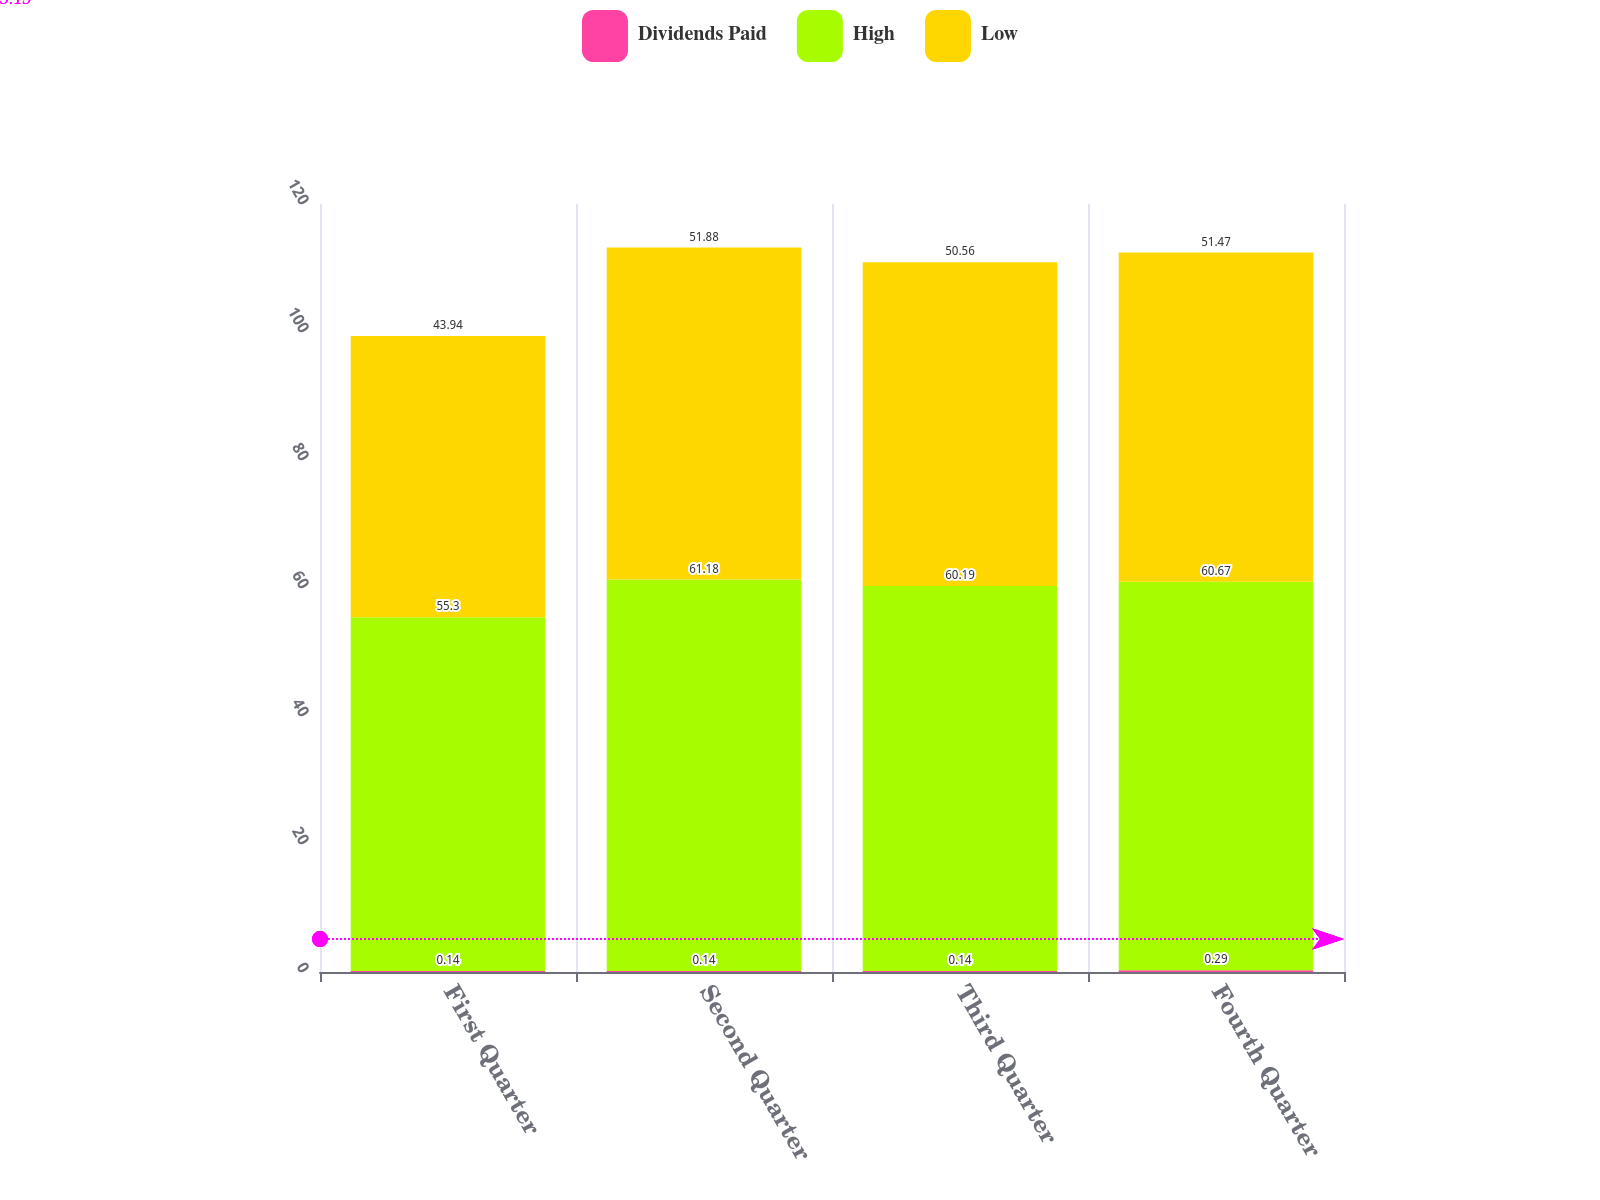Convert chart. <chart><loc_0><loc_0><loc_500><loc_500><stacked_bar_chart><ecel><fcel>First Quarter<fcel>Second Quarter<fcel>Third Quarter<fcel>Fourth Quarter<nl><fcel>Dividends Paid<fcel>0.14<fcel>0.14<fcel>0.14<fcel>0.29<nl><fcel>High<fcel>55.3<fcel>61.18<fcel>60.19<fcel>60.67<nl><fcel>Low<fcel>43.94<fcel>51.88<fcel>50.56<fcel>51.47<nl></chart> 